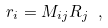<formula> <loc_0><loc_0><loc_500><loc_500>r _ { i } = M _ { i j } R _ { j } \ ,</formula> 